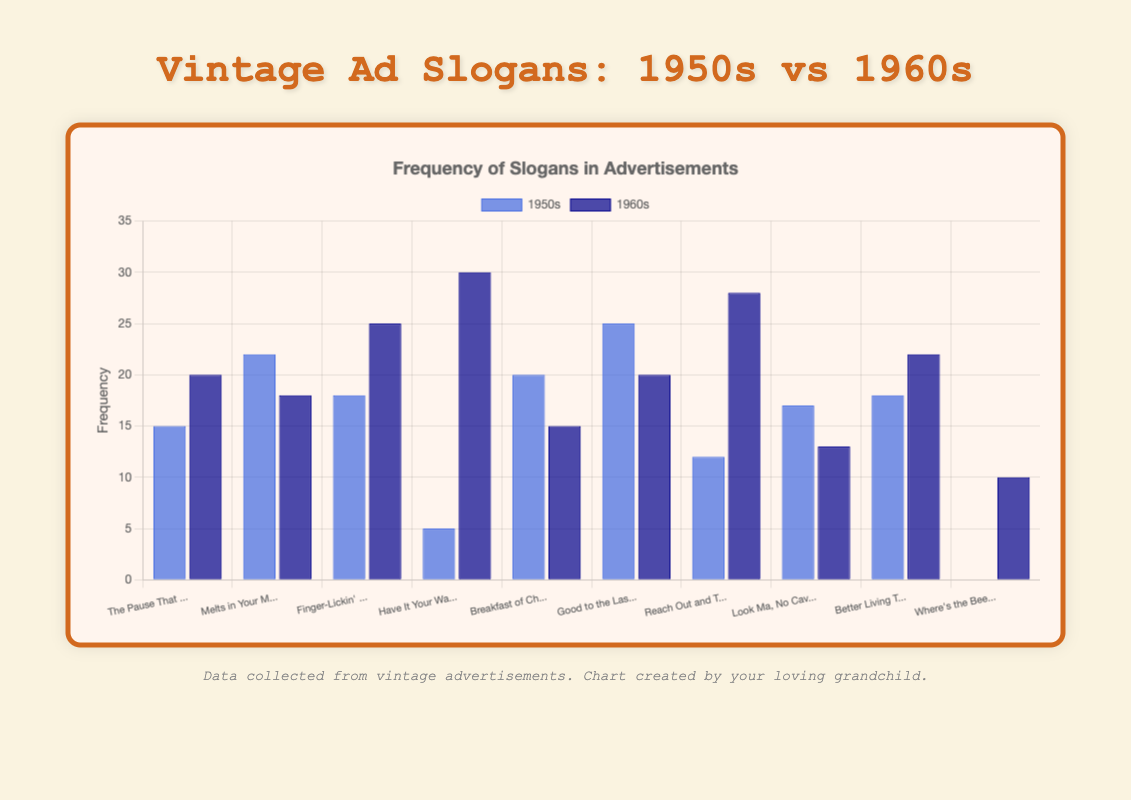Which slogan saw the greatest increase in frequency from the 1950s to the 1960s? First, look at the data for each slogan from both decades. Calculate the difference for each slogan. "Have It Your Way" increased by the most (30 - 5 = 25).
Answer: "Have It Your Way" Which slogan had the highest frequency in the 1950s? Look at all the blue bars and find the tallest one, which corresponds to "Good to the Last Drop" with a frequency of 25.
Answer: "Good to the Last Drop" Which decade used the slogan "Where's the Beef?" more frequently? Compare the blue and dark blue bars for "Where's the Beef?". The dark blue bar (1960s) indicates a frequency of 10, while the blue bar (1950s) shows 0.
Answer: 1960s What is the total frequency of the slogan "Finger-Lickin' Good" for both decades combined? Sum the values for "Finger-Lickin' Good" from the 1950s and 1960s (18 + 25).
Answer: 43 Which slogan saw a decrease in frequency from the 1950s to the 1960s? Check for slogans where the dark blue bar is shorter than the blue bar. "Melts in Your Mouth, Not in Your Hands", "Breakfast of Champions", and "Look Ma, No Cavities!" saw decreases.
Answer: "Melts in Your Mouth, Not in Your Hands," "Breakfast of Champions," and "Look Ma, No Cavities!" What is the average frequency of slogans in the 1960s? Sum the frequencies for all slogans in the 1960s (20 + 18 + 25 + 30 + 15 + 20 + 28 + 13 + 22 + 10 = 201) and divide by the number of slogans (10).
Answer: 20.1 Compare the use of the slogan "Good to the Last Drop" between the two decades. Check the values for "Good to the Last Drop". The frequency is 25 for the 1950s and 20 for the 1960s, showing a decrease.
Answer: Decreased from 25 to 20 Which slogan had the closest frequency values between the two decades? Look at the differences between the 1950s and 1960s frequencies for each slogan. "The Pause That Refreshes" had values 15 and 20, with a difference of 5, which is the smallest difference.
Answer: "The Pause That Refreshes" How many slogans had a frequency of 15 in either the 1950s or the 1960s? Check the frequencies for each slogan in both decades. "The Pause That Refreshes" (1960s), "Breakfast of Champions" (1950s), and "Breakfast of Champions" (1960s) each have a frequency of 15, so there are three instances.
Answer: 3 Which colors represent the decades in the bar chart? Look at the visual attributes of the bars: the blue bars represent the 1950s, and the dark blue bars represent the 1960s.
Answer: Blue for 1950s, dark blue for 1960s 